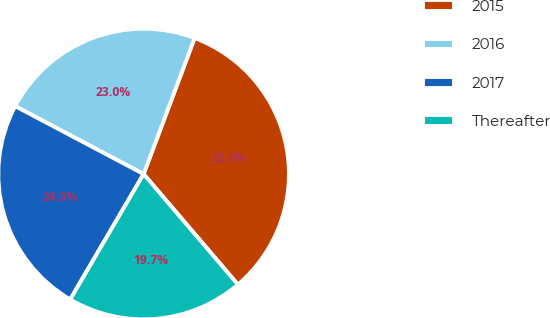<chart> <loc_0><loc_0><loc_500><loc_500><pie_chart><fcel>2015<fcel>2016<fcel>2017<fcel>Thereafter<nl><fcel>33.05%<fcel>22.97%<fcel>24.31%<fcel>19.67%<nl></chart> 